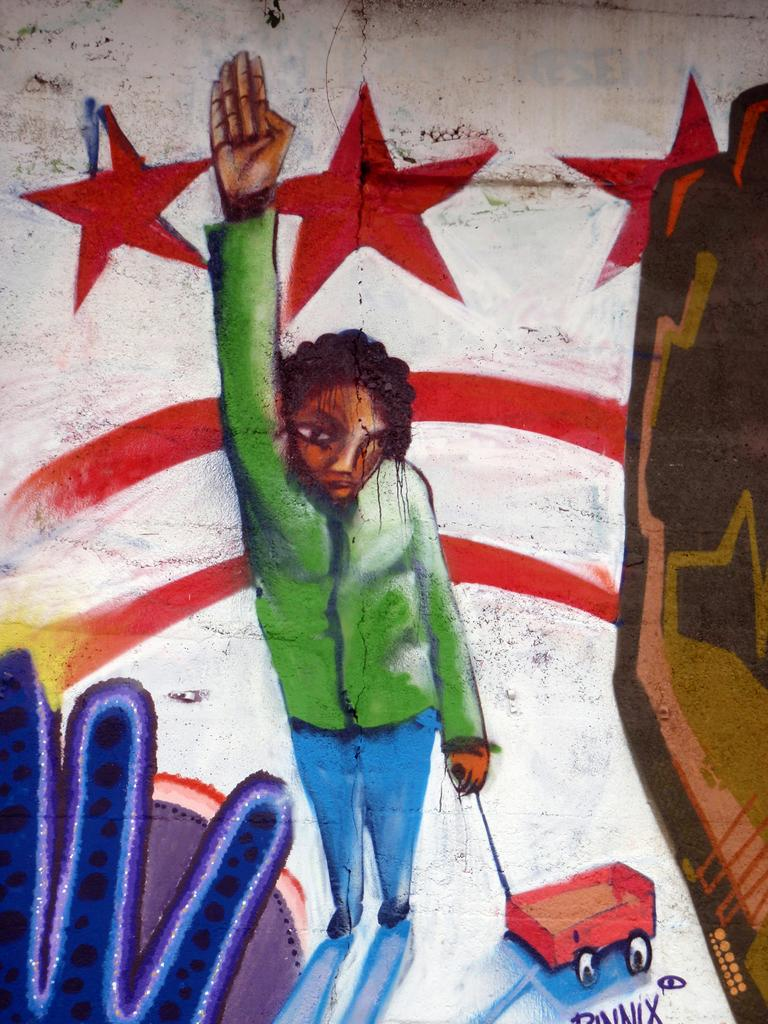What is depicted in the image? There is a painting in the image. What is the main subject of the painting? A person is standing in the painting. What is the person wearing? The person is wearing a green t-shirt. What is the person holding in the painting? The person is holding a trolley. What can be seen in the background of the painting? There are red stars in the background of the painting. What type of bells can be heard ringing in the painting? There are no bells present in the painting, and therefore no sound can be heard. 